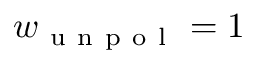Convert formula to latex. <formula><loc_0><loc_0><loc_500><loc_500>w _ { u n p o l } = 1</formula> 